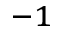Convert formula to latex. <formula><loc_0><loc_0><loc_500><loc_500>^ { - 1 }</formula> 